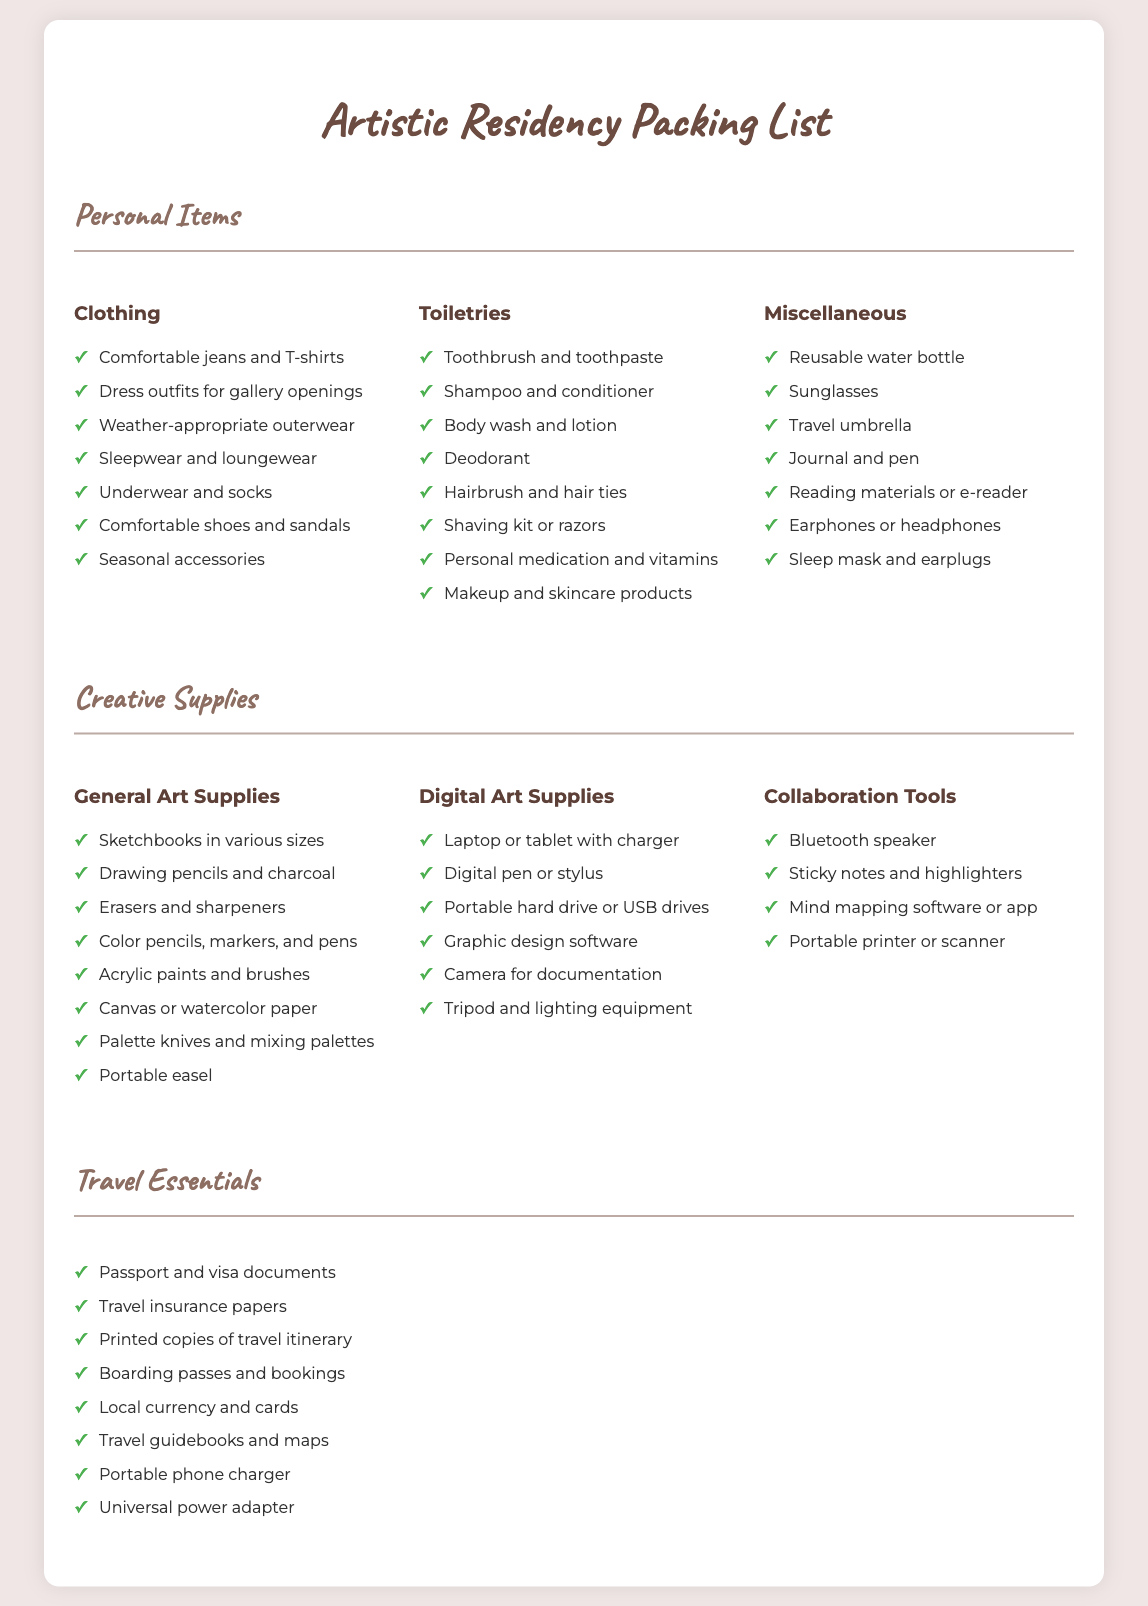what is included in the personal items category? The personal items category consists of clothing, toiletries, and miscellaneous items.
Answer: clothing, toiletries, miscellaneous how many different clothing items are listed? There are seven specific clothing items mentioned in the document.
Answer: seven what type of shoes should be packed? The document specifies comfortable shoes and sandals for the trip.
Answer: comfortable shoes and sandals which digital art supplies are recommended? The digital art supplies section includes several items such as a laptop or tablet with charger, digital pen or stylus, and portable hard drive or USB drives.
Answer: laptop or tablet with charger, digital pen or stylus, portable hard drive or USB drives how many items are listed under travel essentials? There are eight items listed under the travel essentials section.
Answer: eight what is necessary for collaboration tools? Collaboration tools include a Bluetooth speaker, sticky notes, highlighters, mind mapping software or app, and a portable printer or scanner.
Answer: Bluetooth speaker, sticky notes, highlighters, mind mapping software or app, portable printer or scanner which item is suggested for keeping track of ideas and notes? The list under collaboration tools includes sticky notes for keeping track of ideas and notes.
Answer: sticky notes how should one organize their toiletries? Toiletries consist of items such as toothbrush, shampoo, body wash, deodorant, and more, organized into a separate section.
Answer: organized into a separate section what is required for documentation in digital art supplies? A camera for documentation is required under the digital art supplies section.
Answer: camera for documentation 